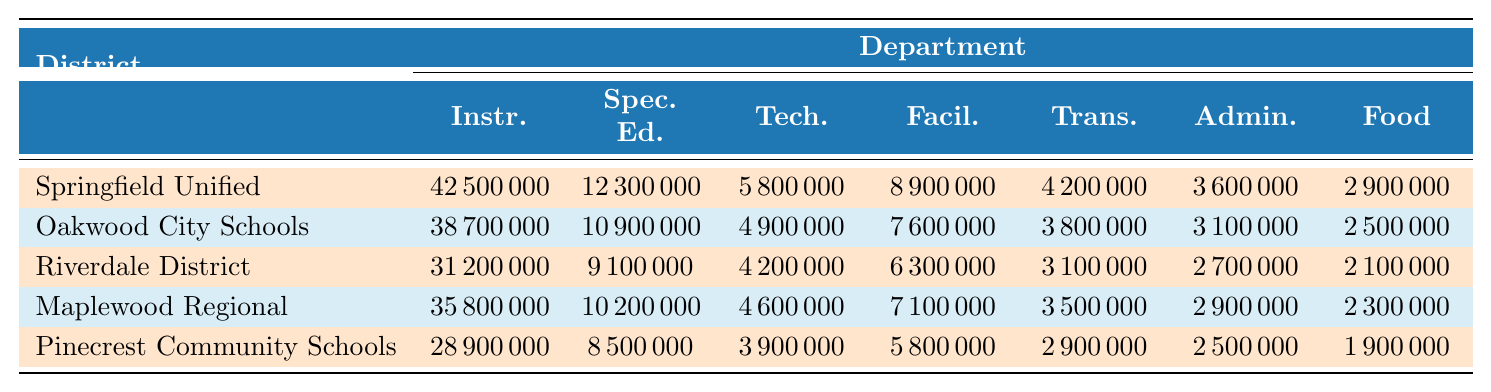What is the total funding allocated to Special Education in Springfield Unified? According to the table, Springfield Unified allocates $12,300,000 to Special Education.
Answer: 12,300,000 Which district has the highest funding for Transportation? By looking at the Transportation values, Springfield Unified has $4,200,000, which is the highest compared to the others.
Answer: Springfield Unified What is the difference in funding between Instruction and Food Services in Maplewood Regional? Maplewood Regional allocates $35,800,000 for Instruction and $2,300,000 for Food Services. The difference is $35,800,000 - $2,300,000 = $33,500,000.
Answer: 33,500,000 Which two districts have the lowest funding allocated to Technology? The table shows Pinecrest Community Schools has $3,900,000 and Riverdale District has $4,200,000 for Technology. Pinecrest has the lowest and Riverdale has the second lowest.
Answer: Pinecrest Community Schools and Riverdale District What is the average funding allocated to Food Services across all districts? The Food Services allocations are $2,900,000 + $2,500,000 + $2,100,000 + $2,300,000 + $1,900,000 = $12,700,000. There are 5 districts, so the average is $12,700,000 / 5 = $2,540,000.
Answer: 2,540,000 Does Oakwood City Schools allocate more money to Administration than to Transportation? Oakwood City Schools allocates $3,100,000 to Administration and $3,800,000 to Transportation. Since $3,100,000 is less than $3,800,000, the answer is no.
Answer: No Which district's total funding allocation is closest to the average funding of all districts? First, sum the total funding for each district: Springfield Unified ($42,500,000) + Oakwood City Schools ($38,700,000) + Riverdale District ($31,200,000) + Maplewood Regional ($35,800,000) + Pinecrest Community Schools ($28,900,000) = $177,100,000. The average is $177,100,000 / 5 = $35,420,000. Comparing the totals, Maplewood Regional at $35,800,000 is closest to $35,420,000.
Answer: Maplewood Regional What percentage of the total funding in Oakwood City Schools is allocated to Instruction? The total funding for Oakwood City Schools is $38,700,000, with $38,700,000 allocated to Instruction. The percentage is ($38,700,000 / $38,700,000) * 100 = 100%.
Answer: 100% 